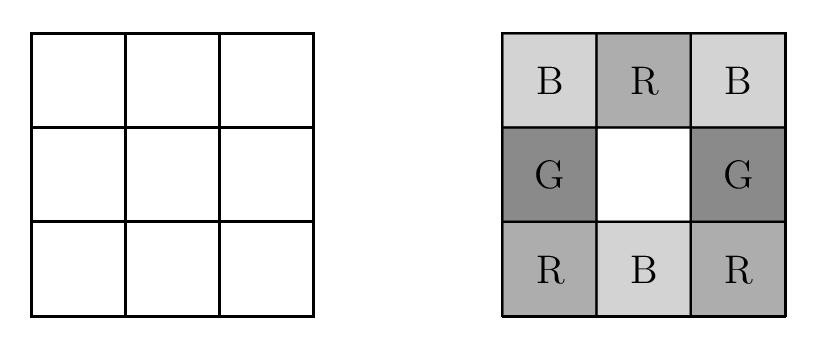Each square in a $3\times 3$ grid of squares is colored red, white, blue, or green so that every $2\times 2$ square contains one square of each color. One such coloring is shown on the right below. How many different colorings are possible? The number of different ways to color a $3\times 3$ grid such that every $2\times 2$ square contains one square of each color red, white, blue, and green is 72. To arrive at this solution, consider that the placement of colors in one $2\times 2$ square largely determines the placement in adjacent squares due to the shared coloring requirement. By calculating permutations that adhere to these conditions across the entire grid, we arrive at 72 feasible configurations. This problem is a form of combinatorial challenge often studied in discrete mathematics, specifically under tiling and coloring problems. 